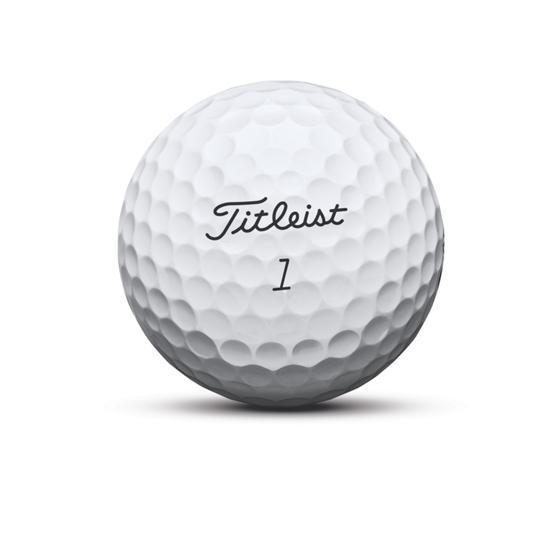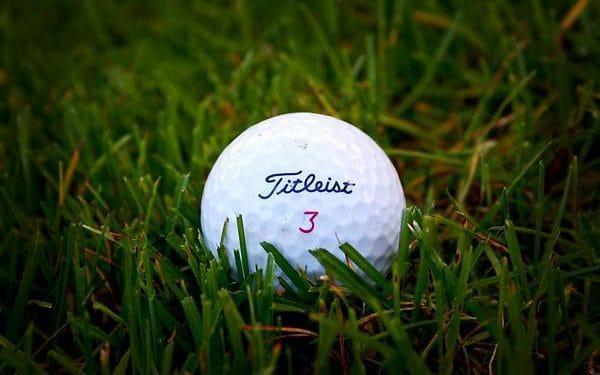The first image is the image on the left, the second image is the image on the right. Examine the images to the left and right. Is the description "There is not less than one golf ball resting on a tee" accurate? Answer yes or no. No. 